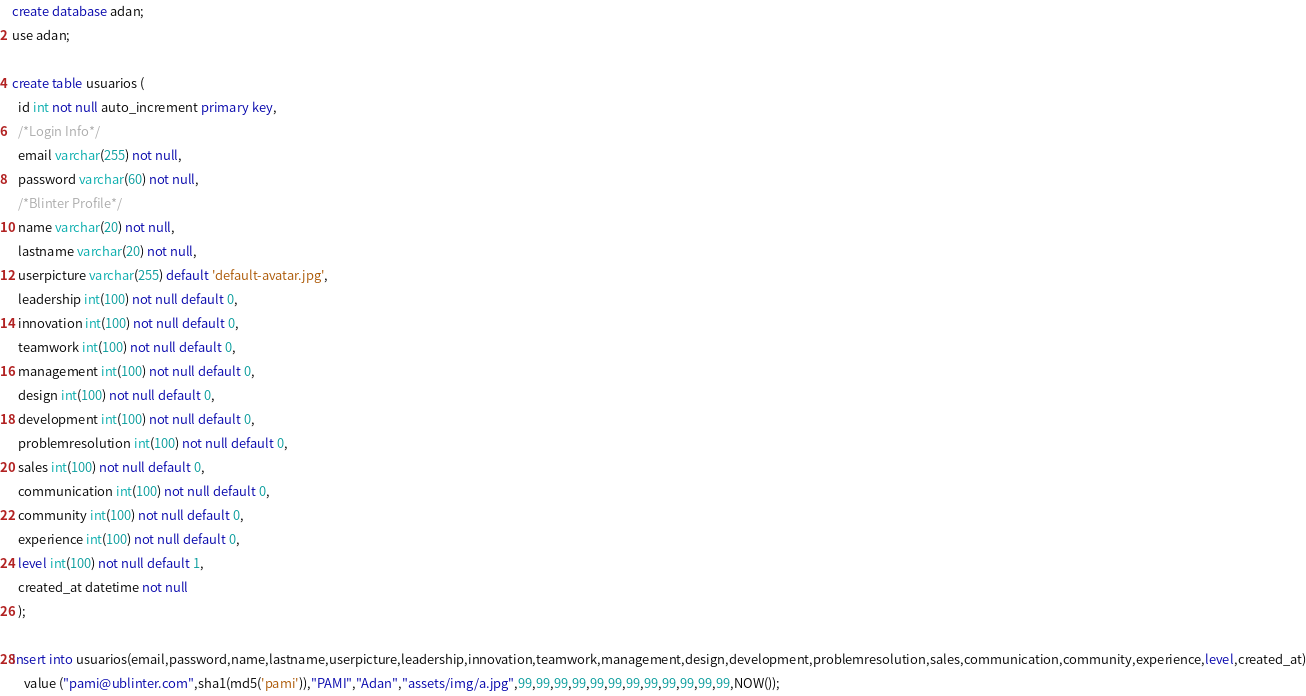Convert code to text. <code><loc_0><loc_0><loc_500><loc_500><_SQL_>create database adan;
use adan;

create table usuarios ( 
  id int not null auto_increment primary key,
  /*Login Info*/
  email varchar(255) not null,
  password varchar(60) not null,
  /*Blinter Profile*/
  name varchar(20) not null,
  lastname varchar(20) not null,
  userpicture varchar(255) default 'default-avatar.jpg',
  leadership int(100) not null default 0,
  innovation int(100) not null default 0,
  teamwork int(100) not null default 0,
  management int(100) not null default 0,
  design int(100) not null default 0,
  development int(100) not null default 0,
  problemresolution int(100) not null default 0,
  sales int(100) not null default 0,
  communication int(100) not null default 0,
  community int(100) not null default 0,
  experience int(100) not null default 0,
  level int(100) not null default 1,
  created_at datetime not null
  );

insert into usuarios(email,password,name,lastname,userpicture,leadership,innovation,teamwork,management,design,development,problemresolution,sales,communication,community,experience,level,created_at)
	value ("pami@ublinter.com",sha1(md5('pami')),"PAMI","Adan","assets/img/a.jpg",99,99,99,99,99,99,99,99,99,99,99,99,NOW());</code> 